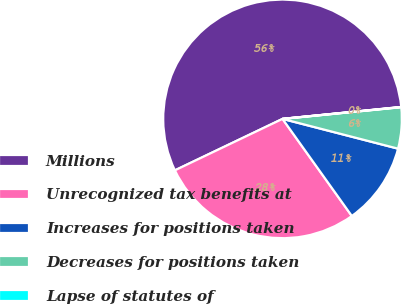Convert chart to OTSL. <chart><loc_0><loc_0><loc_500><loc_500><pie_chart><fcel>Millions<fcel>Unrecognized tax benefits at<fcel>Increases for positions taken<fcel>Decreases for positions taken<fcel>Lapse of statutes of<nl><fcel>55.51%<fcel>27.77%<fcel>11.12%<fcel>5.58%<fcel>0.03%<nl></chart> 